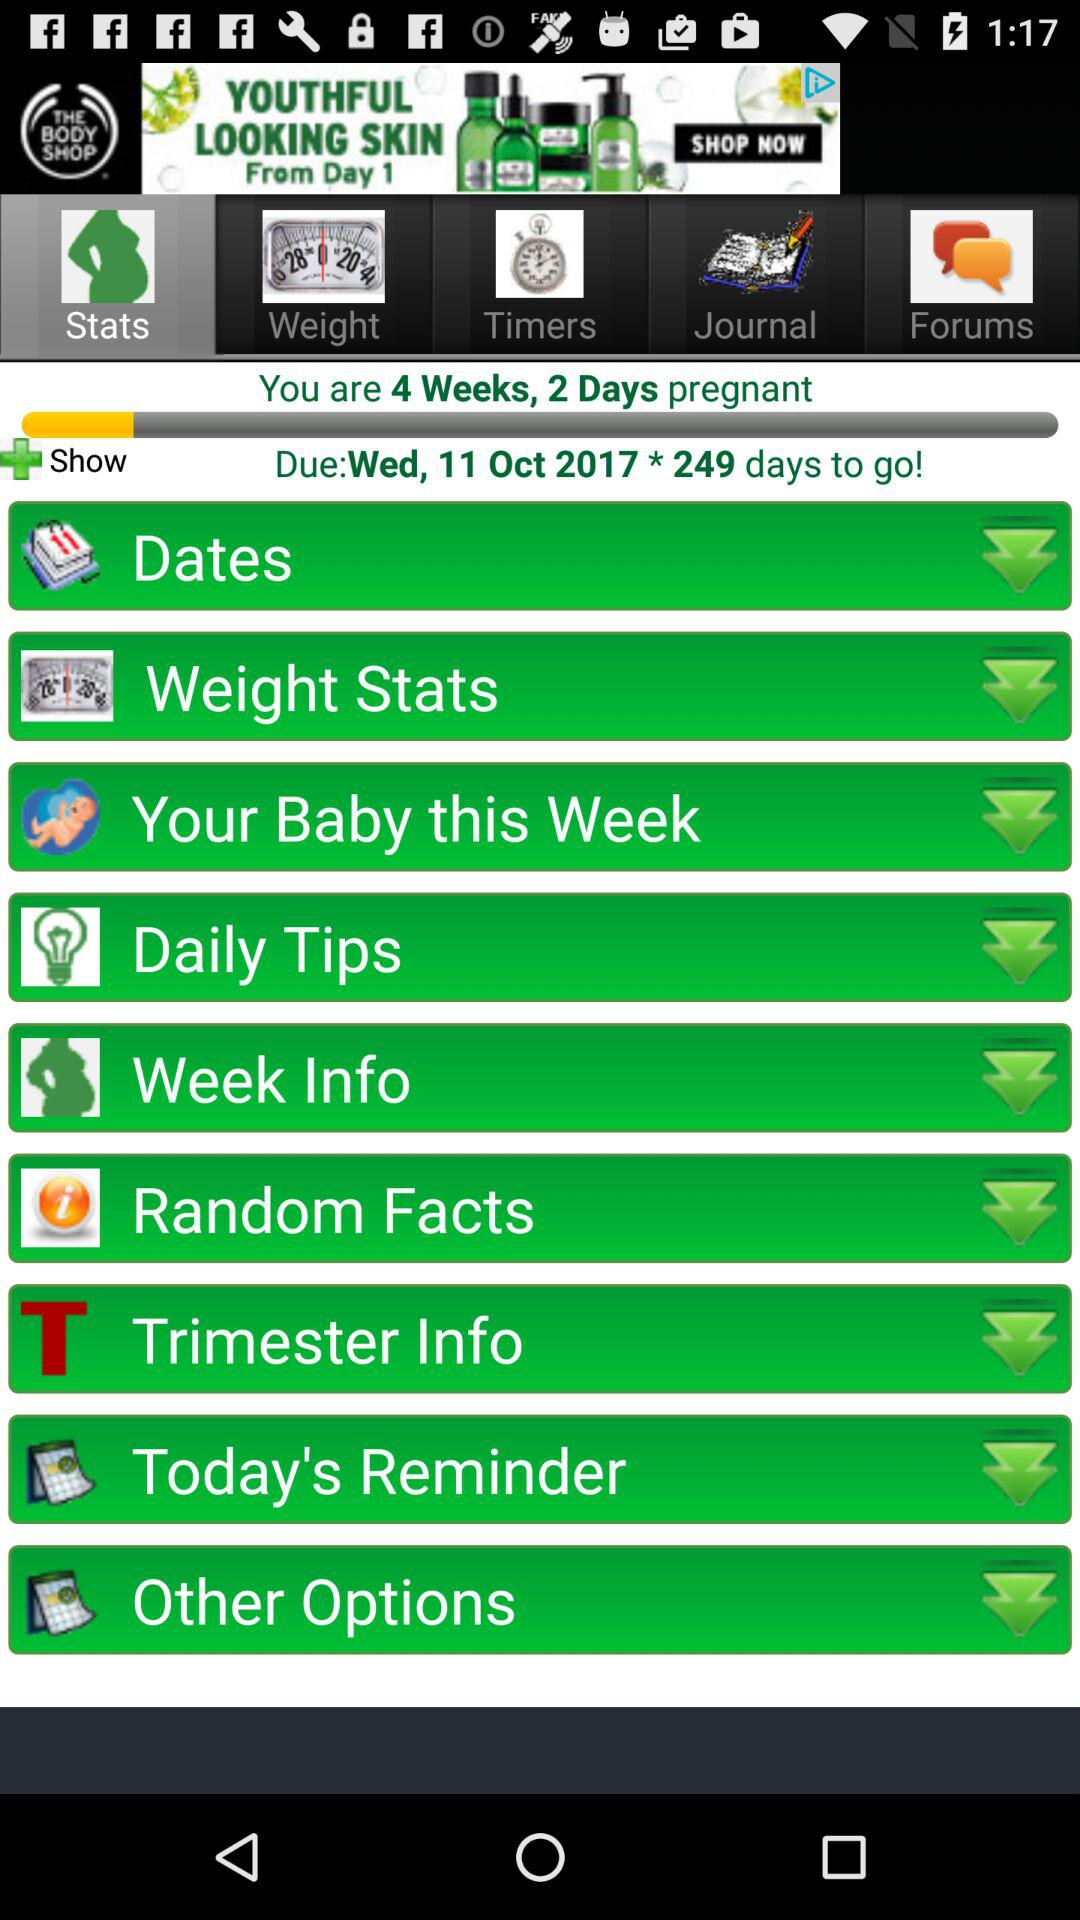What is the duration of pregnancy? The duration is 4 weeks and 2 days. 